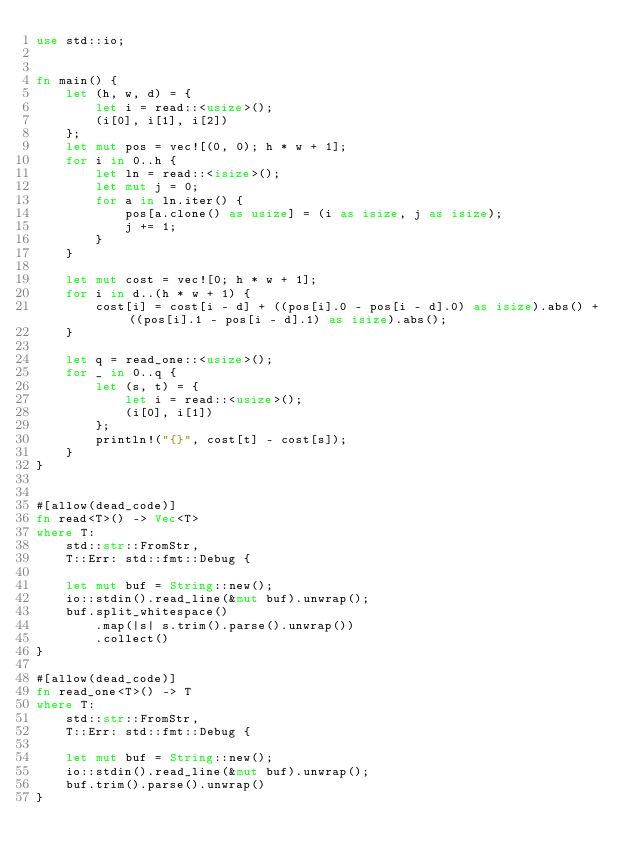Convert code to text. <code><loc_0><loc_0><loc_500><loc_500><_Rust_>use std::io;


fn main() {
    let (h, w, d) = {
        let i = read::<usize>();
        (i[0], i[1], i[2])
    };
    let mut pos = vec![(0, 0); h * w + 1];
    for i in 0..h {
        let ln = read::<isize>();
        let mut j = 0;
        for a in ln.iter() {
            pos[a.clone() as usize] = (i as isize, j as isize);
            j += 1;
        }
    }

    let mut cost = vec![0; h * w + 1];
    for i in d..(h * w + 1) {
        cost[i] = cost[i - d] + ((pos[i].0 - pos[i - d].0) as isize).abs() + ((pos[i].1 - pos[i - d].1) as isize).abs();
    }

    let q = read_one::<usize>();
    for _ in 0..q {
        let (s, t) = {
            let i = read::<usize>();
            (i[0], i[1])
        };
        println!("{}", cost[t] - cost[s]);
    }
}


#[allow(dead_code)]
fn read<T>() -> Vec<T>
where T:
    std::str::FromStr,
    T::Err: std::fmt::Debug {

    let mut buf = String::new();
    io::stdin().read_line(&mut buf).unwrap();
    buf.split_whitespace()
        .map(|s| s.trim().parse().unwrap())
        .collect()
}

#[allow(dead_code)]
fn read_one<T>() -> T
where T:
    std::str::FromStr,
    T::Err: std::fmt::Debug {

    let mut buf = String::new();
    io::stdin().read_line(&mut buf).unwrap();
    buf.trim().parse().unwrap()
}</code> 